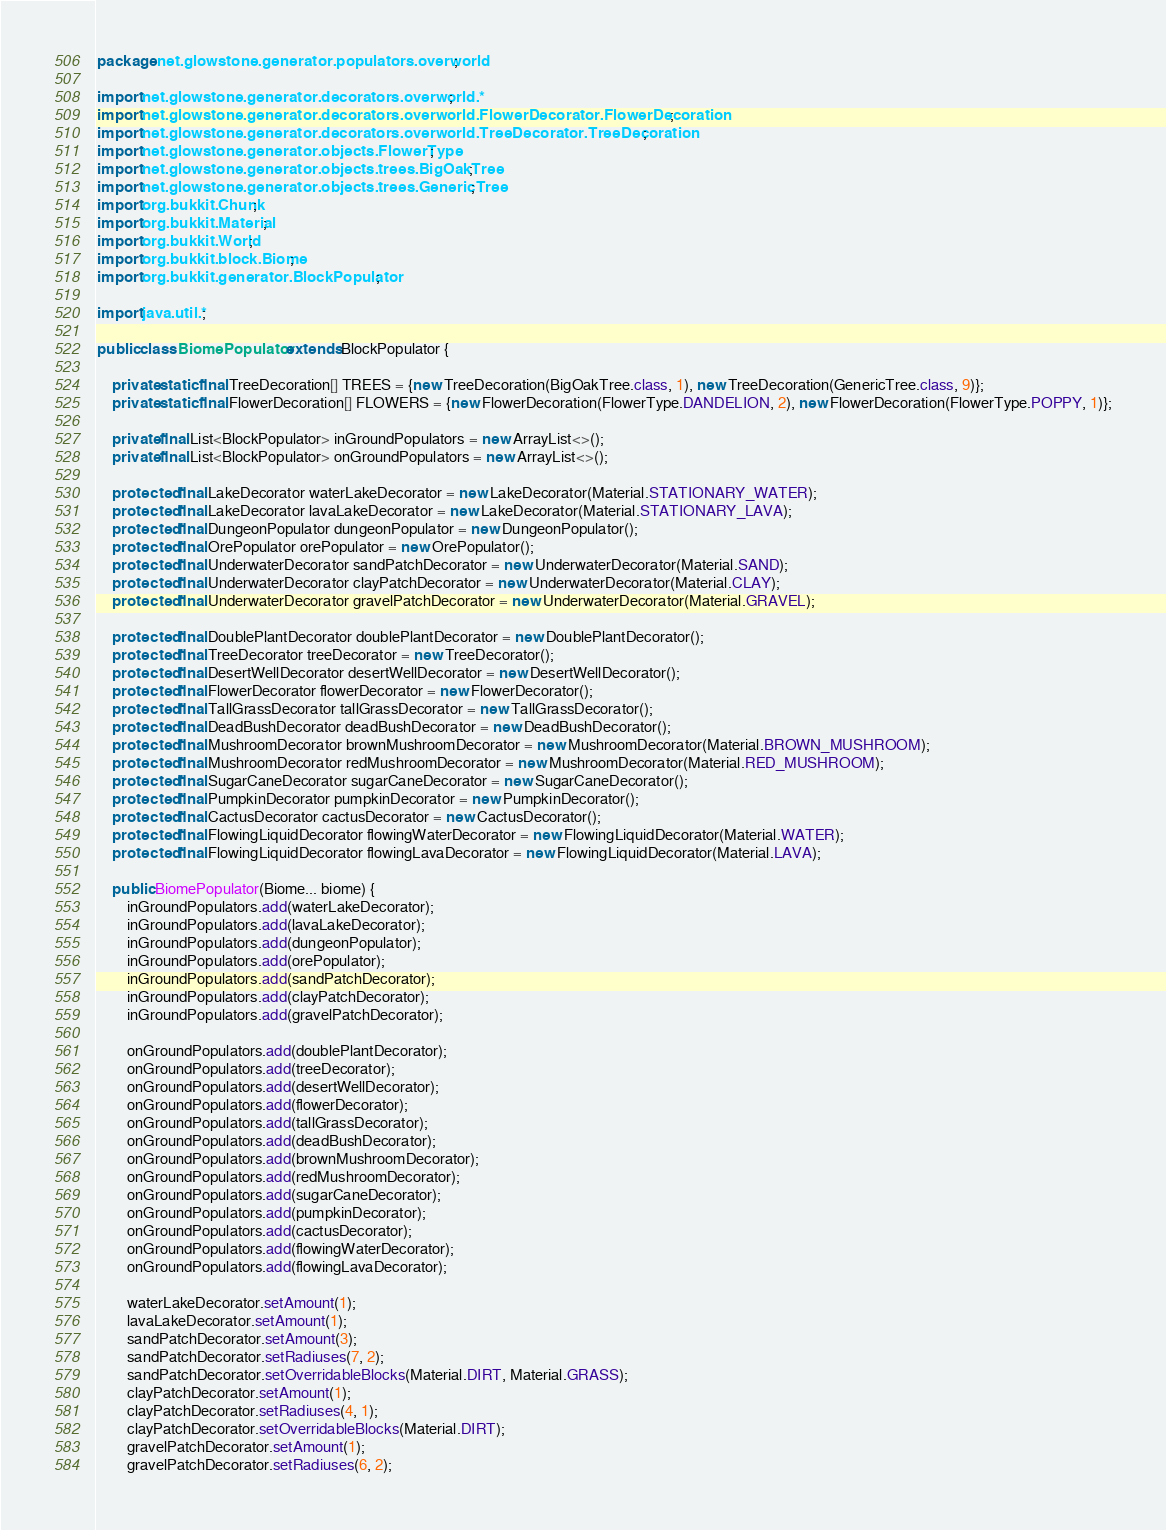Convert code to text. <code><loc_0><loc_0><loc_500><loc_500><_Java_>package net.glowstone.generator.populators.overworld;

import net.glowstone.generator.decorators.overworld.*;
import net.glowstone.generator.decorators.overworld.FlowerDecorator.FlowerDecoration;
import net.glowstone.generator.decorators.overworld.TreeDecorator.TreeDecoration;
import net.glowstone.generator.objects.FlowerType;
import net.glowstone.generator.objects.trees.BigOakTree;
import net.glowstone.generator.objects.trees.GenericTree;
import org.bukkit.Chunk;
import org.bukkit.Material;
import org.bukkit.World;
import org.bukkit.block.Biome;
import org.bukkit.generator.BlockPopulator;

import java.util.*;

public class BiomePopulator extends BlockPopulator {

    private static final TreeDecoration[] TREES = {new TreeDecoration(BigOakTree.class, 1), new TreeDecoration(GenericTree.class, 9)};
    private static final FlowerDecoration[] FLOWERS = {new FlowerDecoration(FlowerType.DANDELION, 2), new FlowerDecoration(FlowerType.POPPY, 1)};

    private final List<BlockPopulator> inGroundPopulators = new ArrayList<>();
    private final List<BlockPopulator> onGroundPopulators = new ArrayList<>();

    protected final LakeDecorator waterLakeDecorator = new LakeDecorator(Material.STATIONARY_WATER);
    protected final LakeDecorator lavaLakeDecorator = new LakeDecorator(Material.STATIONARY_LAVA);
    protected final DungeonPopulator dungeonPopulator = new DungeonPopulator();
    protected final OrePopulator orePopulator = new OrePopulator();
    protected final UnderwaterDecorator sandPatchDecorator = new UnderwaterDecorator(Material.SAND);
    protected final UnderwaterDecorator clayPatchDecorator = new UnderwaterDecorator(Material.CLAY);
    protected final UnderwaterDecorator gravelPatchDecorator = new UnderwaterDecorator(Material.GRAVEL);

    protected final DoublePlantDecorator doublePlantDecorator = new DoublePlantDecorator();
    protected final TreeDecorator treeDecorator = new TreeDecorator();
    protected final DesertWellDecorator desertWellDecorator = new DesertWellDecorator();
    protected final FlowerDecorator flowerDecorator = new FlowerDecorator();
    protected final TallGrassDecorator tallGrassDecorator = new TallGrassDecorator();
    protected final DeadBushDecorator deadBushDecorator = new DeadBushDecorator();
    protected final MushroomDecorator brownMushroomDecorator = new MushroomDecorator(Material.BROWN_MUSHROOM);
    protected final MushroomDecorator redMushroomDecorator = new MushroomDecorator(Material.RED_MUSHROOM);   
    protected final SugarCaneDecorator sugarCaneDecorator = new SugarCaneDecorator();
    protected final PumpkinDecorator pumpkinDecorator = new PumpkinDecorator();
    protected final CactusDecorator cactusDecorator = new CactusDecorator();
    protected final FlowingLiquidDecorator flowingWaterDecorator = new FlowingLiquidDecorator(Material.WATER);
    protected final FlowingLiquidDecorator flowingLavaDecorator = new FlowingLiquidDecorator(Material.LAVA);

    public BiomePopulator(Biome... biome) {
        inGroundPopulators.add(waterLakeDecorator);
        inGroundPopulators.add(lavaLakeDecorator);
        inGroundPopulators.add(dungeonPopulator);
        inGroundPopulators.add(orePopulator);
        inGroundPopulators.add(sandPatchDecorator);
        inGroundPopulators.add(clayPatchDecorator);
        inGroundPopulators.add(gravelPatchDecorator);

        onGroundPopulators.add(doublePlantDecorator);
        onGroundPopulators.add(treeDecorator);
        onGroundPopulators.add(desertWellDecorator);
        onGroundPopulators.add(flowerDecorator);
        onGroundPopulators.add(tallGrassDecorator);
        onGroundPopulators.add(deadBushDecorator);
        onGroundPopulators.add(brownMushroomDecorator);
        onGroundPopulators.add(redMushroomDecorator);
        onGroundPopulators.add(sugarCaneDecorator);
        onGroundPopulators.add(pumpkinDecorator);
        onGroundPopulators.add(cactusDecorator);
        onGroundPopulators.add(flowingWaterDecorator);
        onGroundPopulators.add(flowingLavaDecorator);

        waterLakeDecorator.setAmount(1);
        lavaLakeDecorator.setAmount(1);
        sandPatchDecorator.setAmount(3);
        sandPatchDecorator.setRadiuses(7, 2);
        sandPatchDecorator.setOverridableBlocks(Material.DIRT, Material.GRASS);
        clayPatchDecorator.setAmount(1);
        clayPatchDecorator.setRadiuses(4, 1);
        clayPatchDecorator.setOverridableBlocks(Material.DIRT);
        gravelPatchDecorator.setAmount(1);
        gravelPatchDecorator.setRadiuses(6, 2);</code> 